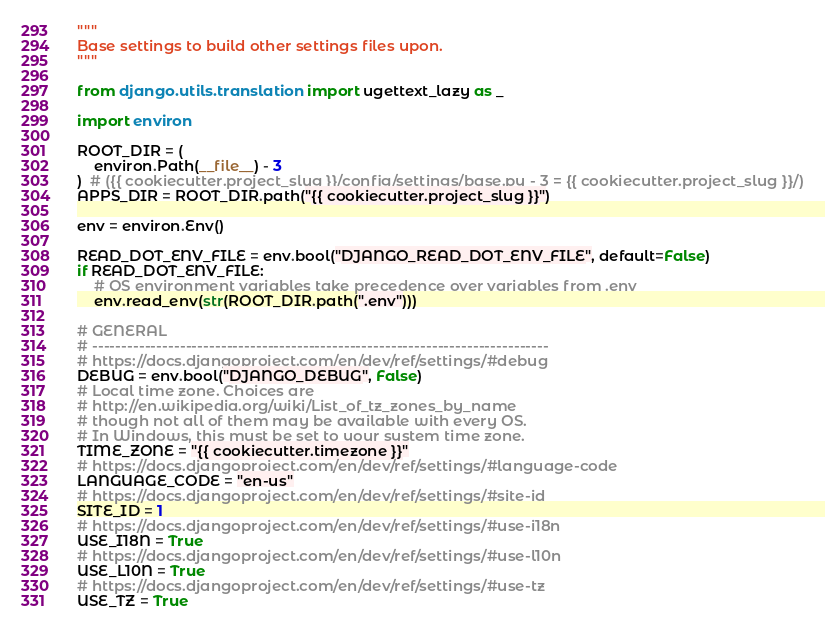<code> <loc_0><loc_0><loc_500><loc_500><_Python_>"""
Base settings to build other settings files upon.
"""

from django.utils.translation import ugettext_lazy as _

import environ

ROOT_DIR = (
    environ.Path(__file__) - 3
)  # ({{ cookiecutter.project_slug }}/config/settings/base.py - 3 = {{ cookiecutter.project_slug }}/)
APPS_DIR = ROOT_DIR.path("{{ cookiecutter.project_slug }}")

env = environ.Env()

READ_DOT_ENV_FILE = env.bool("DJANGO_READ_DOT_ENV_FILE", default=False)
if READ_DOT_ENV_FILE:
    # OS environment variables take precedence over variables from .env
    env.read_env(str(ROOT_DIR.path(".env")))

# GENERAL
# ------------------------------------------------------------------------------
# https://docs.djangoproject.com/en/dev/ref/settings/#debug
DEBUG = env.bool("DJANGO_DEBUG", False)
# Local time zone. Choices are
# http://en.wikipedia.org/wiki/List_of_tz_zones_by_name
# though not all of them may be available with every OS.
# In Windows, this must be set to your system time zone.
TIME_ZONE = "{{ cookiecutter.timezone }}"
# https://docs.djangoproject.com/en/dev/ref/settings/#language-code
LANGUAGE_CODE = "en-us"
# https://docs.djangoproject.com/en/dev/ref/settings/#site-id
SITE_ID = 1
# https://docs.djangoproject.com/en/dev/ref/settings/#use-i18n
USE_I18N = True
# https://docs.djangoproject.com/en/dev/ref/settings/#use-l10n
USE_L10N = True
# https://docs.djangoproject.com/en/dev/ref/settings/#use-tz
USE_TZ = True</code> 